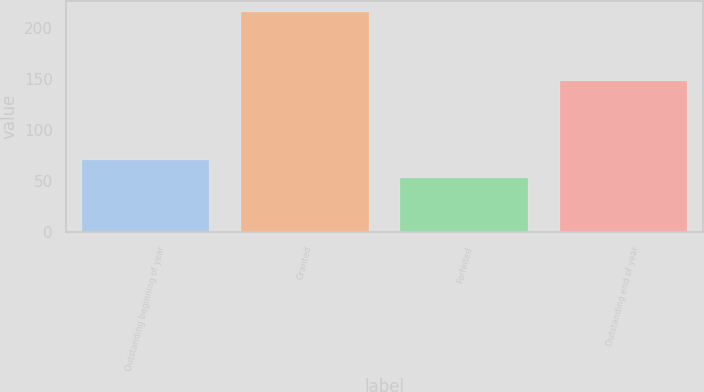Convert chart. <chart><loc_0><loc_0><loc_500><loc_500><bar_chart><fcel>Outstanding beginning of year<fcel>Granted<fcel>Forfeited<fcel>Outstanding end of year<nl><fcel>71.03<fcel>215.76<fcel>53.36<fcel>148.22<nl></chart> 